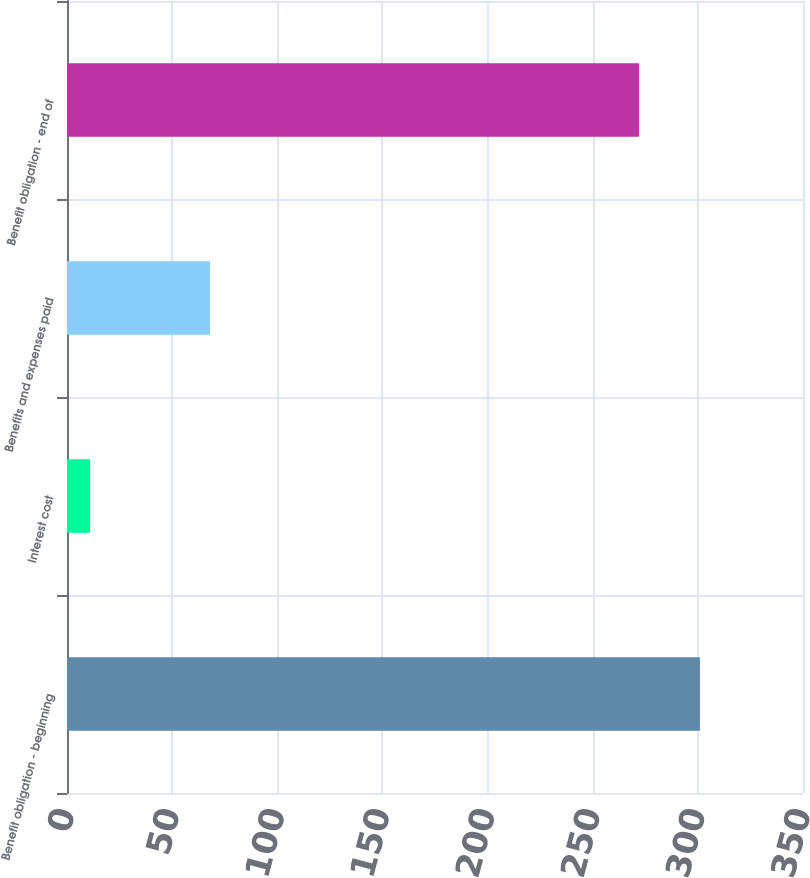Convert chart. <chart><loc_0><loc_0><loc_500><loc_500><bar_chart><fcel>Benefit obligation - beginning<fcel>Interest cost<fcel>Benefits and expenses paid<fcel>Benefit obligation - end of<nl><fcel>301<fcel>11<fcel>68<fcel>272<nl></chart> 